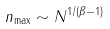Convert formula to latex. <formula><loc_0><loc_0><loc_500><loc_500>n _ { \max } \sim N ^ { 1 / ( \beta - 1 ) }</formula> 